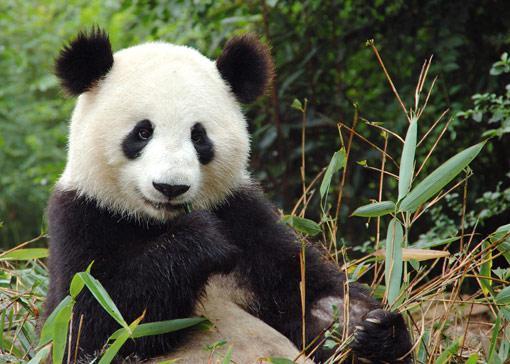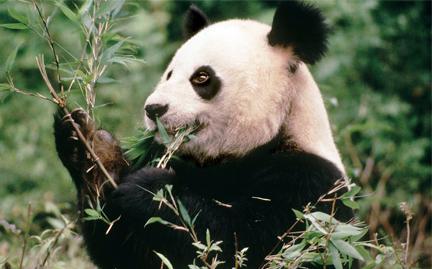The first image is the image on the left, the second image is the image on the right. For the images displayed, is the sentence "The panda on the left image is on a tree branch." factually correct? Answer yes or no. No. 